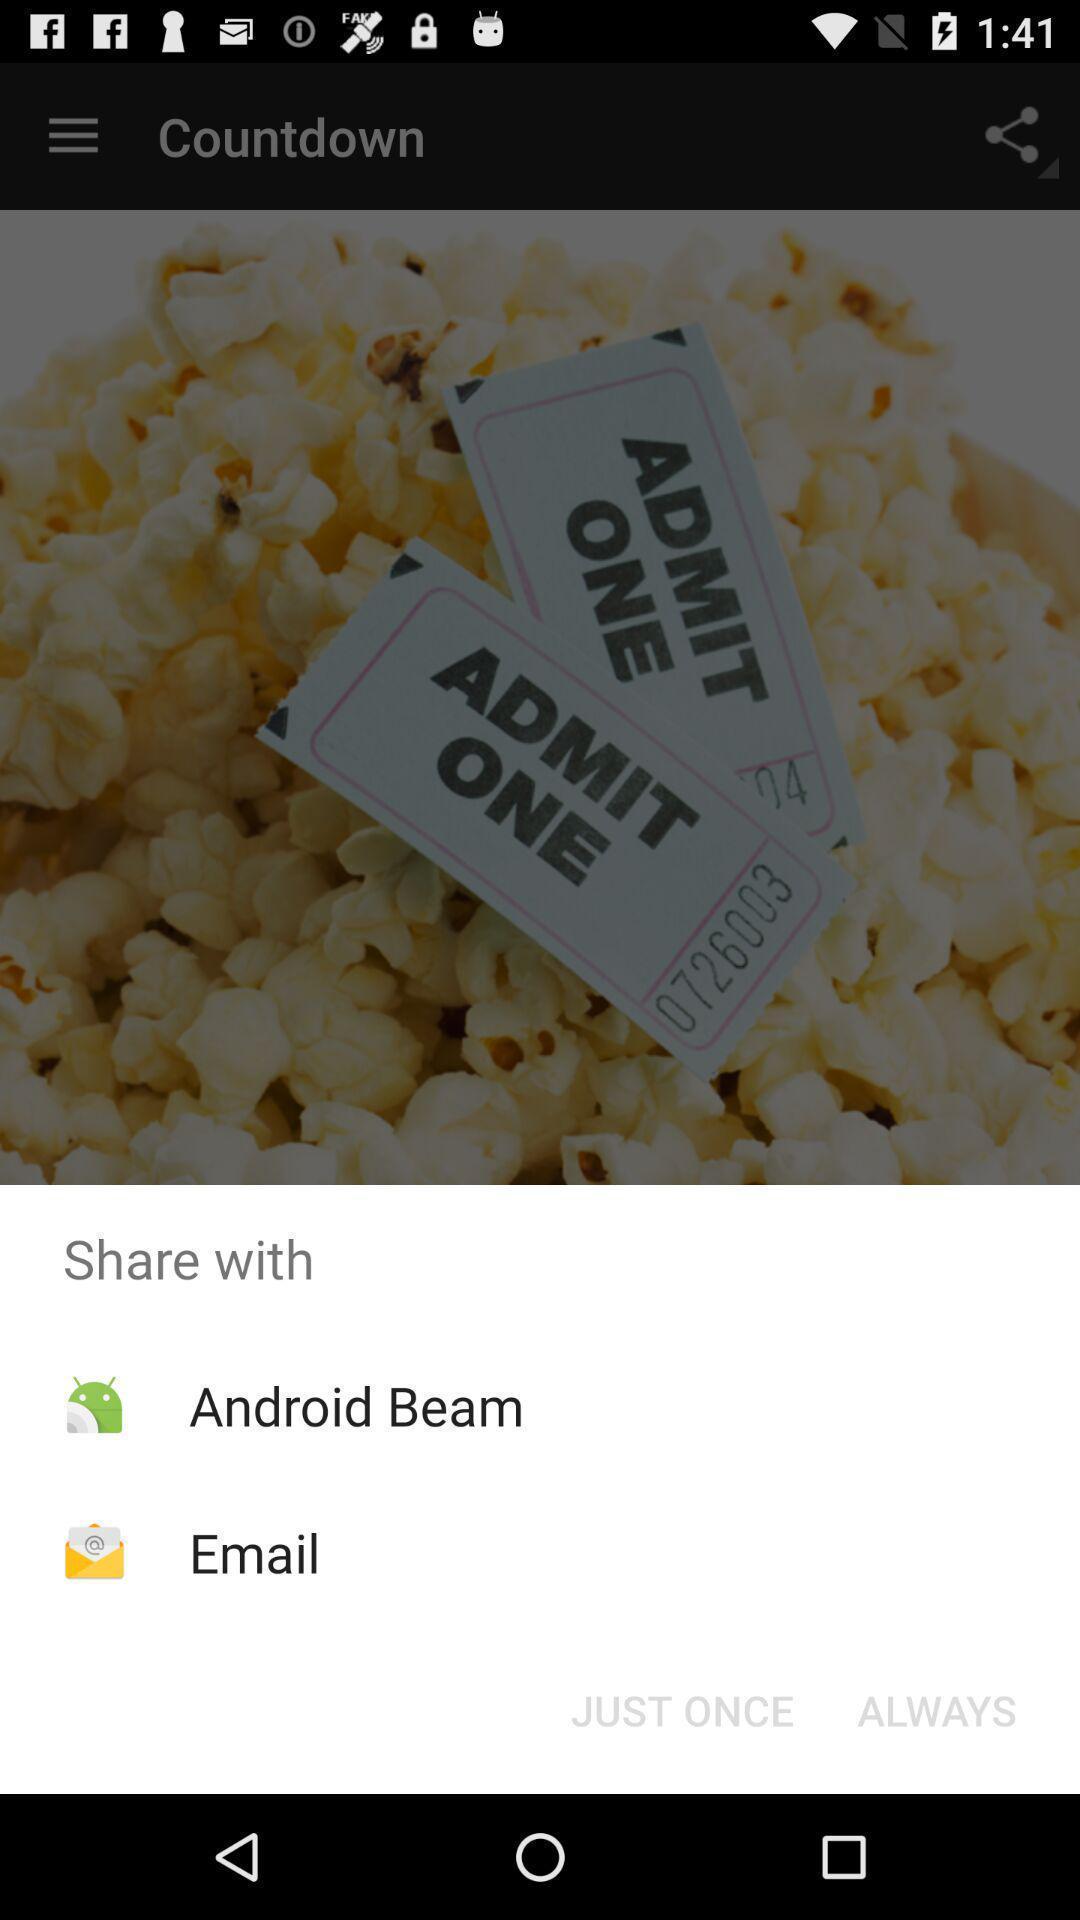Summarize the main components in this picture. Push up message for sharing data via social network. 